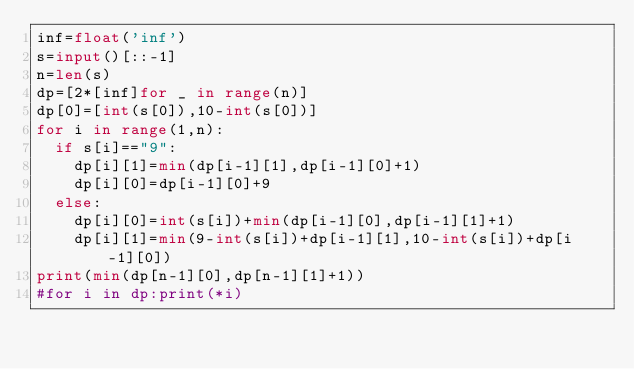Convert code to text. <code><loc_0><loc_0><loc_500><loc_500><_Python_>inf=float('inf')
s=input()[::-1]
n=len(s)
dp=[2*[inf]for _ in range(n)]
dp[0]=[int(s[0]),10-int(s[0])]
for i in range(1,n):
  if s[i]=="9":
    dp[i][1]=min(dp[i-1][1],dp[i-1][0]+1)
    dp[i][0]=dp[i-1][0]+9
  else:
    dp[i][0]=int(s[i])+min(dp[i-1][0],dp[i-1][1]+1)
    dp[i][1]=min(9-int(s[i])+dp[i-1][1],10-int(s[i])+dp[i-1][0])
print(min(dp[n-1][0],dp[n-1][1]+1))
#for i in dp:print(*i)</code> 